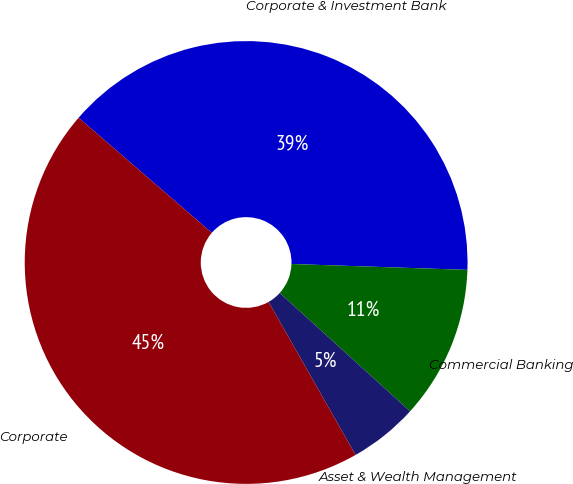Convert chart to OTSL. <chart><loc_0><loc_0><loc_500><loc_500><pie_chart><fcel>Corporate & Investment Bank<fcel>Commercial Banking<fcel>Asset & Wealth Management<fcel>Corporate<nl><fcel>39.19%<fcel>11.2%<fcel>5.04%<fcel>44.57%<nl></chart> 